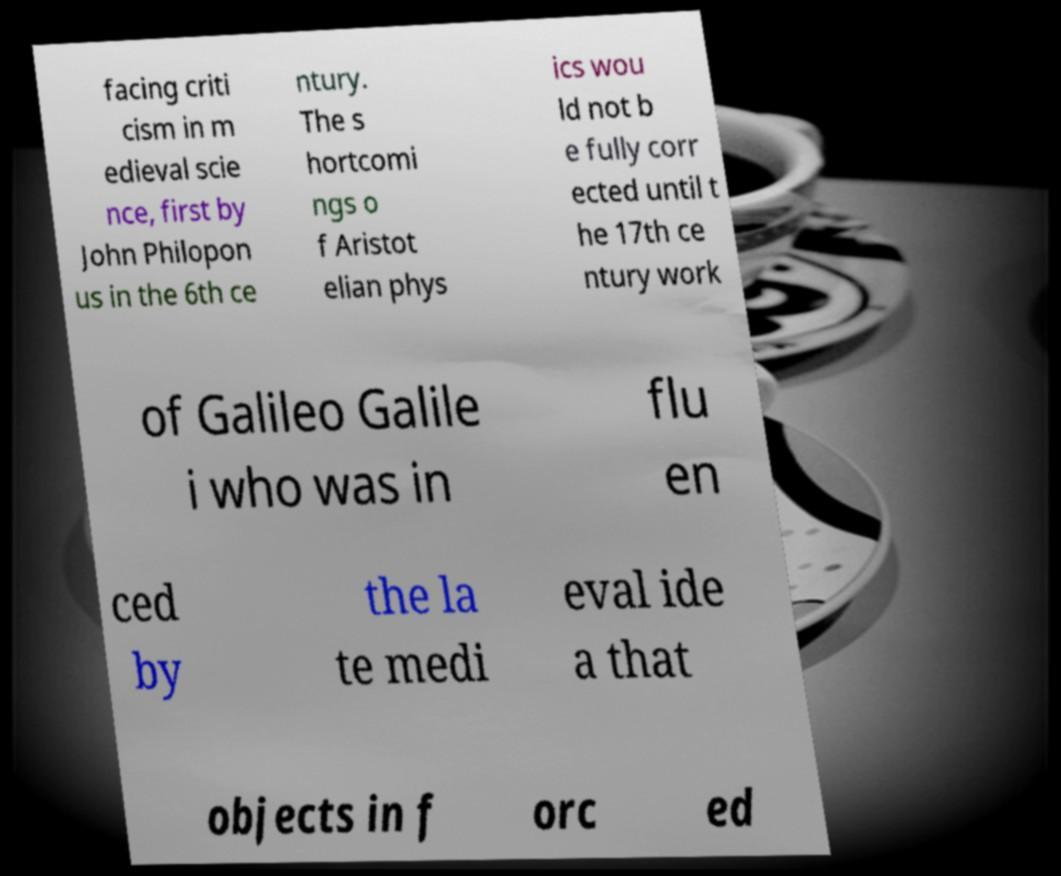There's text embedded in this image that I need extracted. Can you transcribe it verbatim? facing criti cism in m edieval scie nce, first by John Philopon us in the 6th ce ntury. The s hortcomi ngs o f Aristot elian phys ics wou ld not b e fully corr ected until t he 17th ce ntury work of Galileo Galile i who was in flu en ced by the la te medi eval ide a that objects in f orc ed 